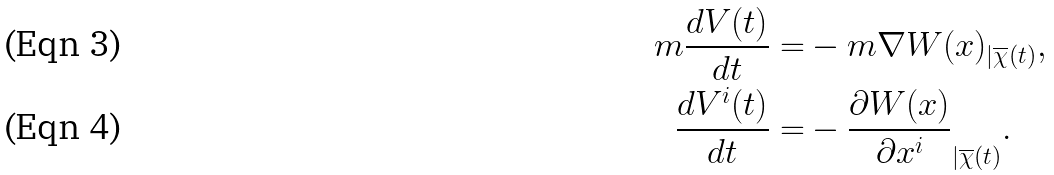Convert formula to latex. <formula><loc_0><loc_0><loc_500><loc_500>m \frac { d V ( t ) } { d t } = & - m \nabla W ( x ) _ { | \overline { \chi } ( t ) } , \\ \frac { d V ^ { i } ( t ) } { d t } = & - \frac { \partial W ( x ) } { \partial x ^ { i } } _ { | \overline { \chi } ( t ) } .</formula> 